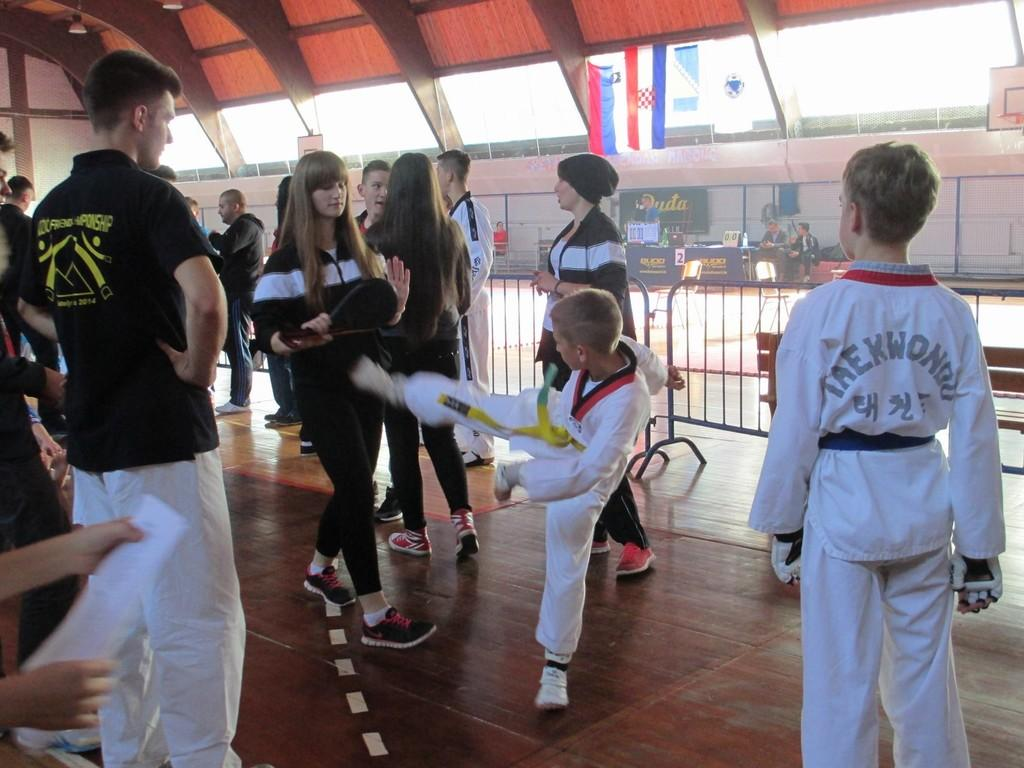<image>
Give a short and clear explanation of the subsequent image. Youth athletes wearing white uniforms with Taekwondo on the back in gray. 